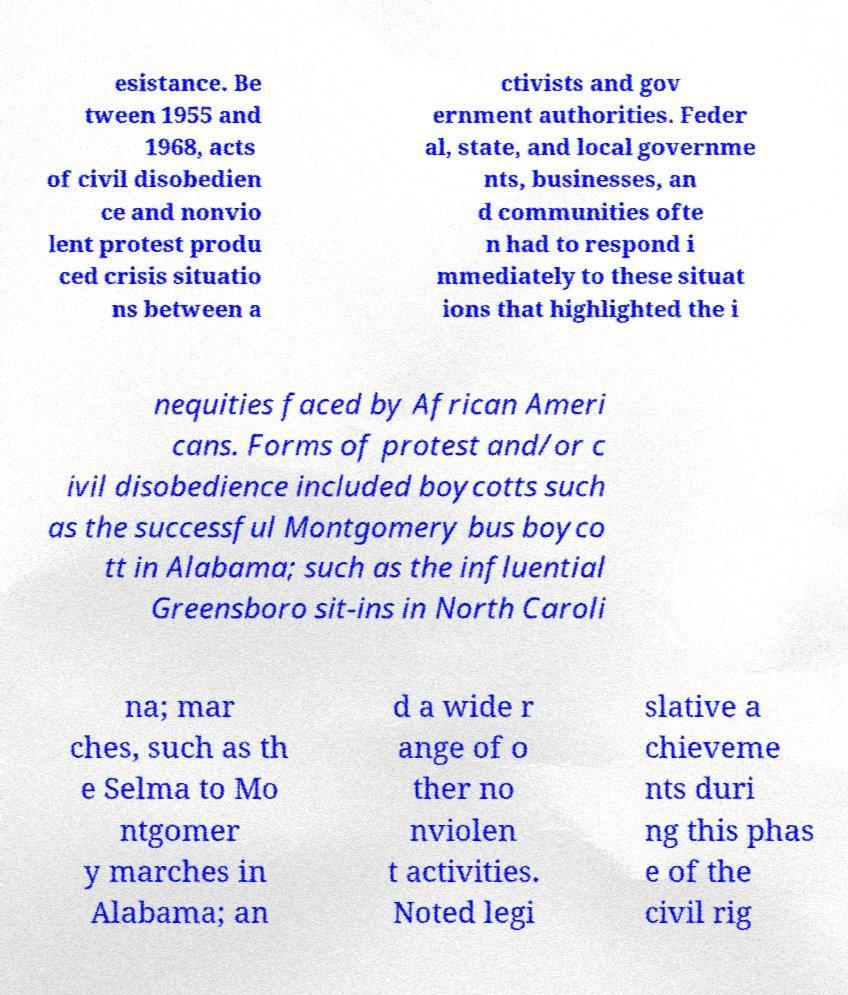I need the written content from this picture converted into text. Can you do that? esistance. Be tween 1955 and 1968, acts of civil disobedien ce and nonvio lent protest produ ced crisis situatio ns between a ctivists and gov ernment authorities. Feder al, state, and local governme nts, businesses, an d communities ofte n had to respond i mmediately to these situat ions that highlighted the i nequities faced by African Ameri cans. Forms of protest and/or c ivil disobedience included boycotts such as the successful Montgomery bus boyco tt in Alabama; such as the influential Greensboro sit-ins in North Caroli na; mar ches, such as th e Selma to Mo ntgomer y marches in Alabama; an d a wide r ange of o ther no nviolen t activities. Noted legi slative a chieveme nts duri ng this phas e of the civil rig 